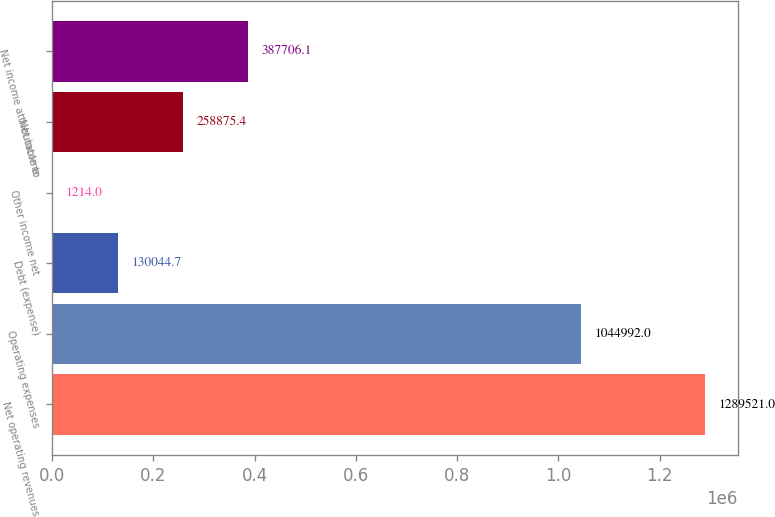Convert chart. <chart><loc_0><loc_0><loc_500><loc_500><bar_chart><fcel>Net operating revenues<fcel>Operating expenses<fcel>Debt (expense)<fcel>Other income net<fcel>Net income<fcel>Net income attributable to<nl><fcel>1.28952e+06<fcel>1.04499e+06<fcel>130045<fcel>1214<fcel>258875<fcel>387706<nl></chart> 